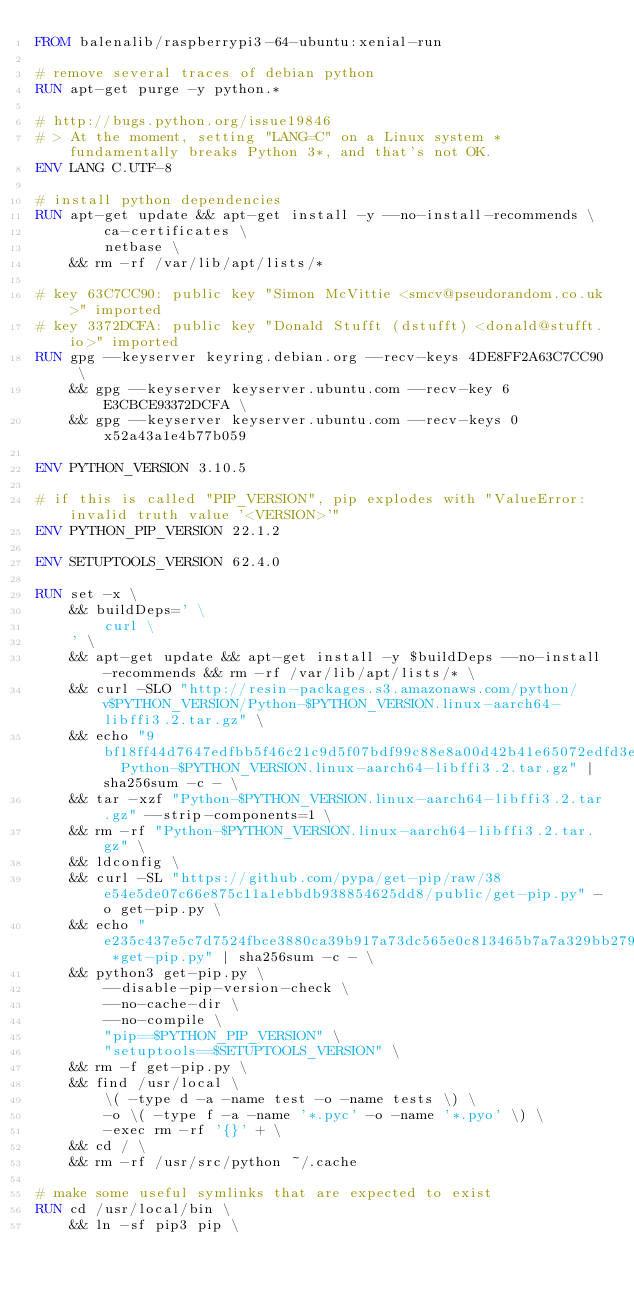<code> <loc_0><loc_0><loc_500><loc_500><_Dockerfile_>FROM balenalib/raspberrypi3-64-ubuntu:xenial-run

# remove several traces of debian python
RUN apt-get purge -y python.*

# http://bugs.python.org/issue19846
# > At the moment, setting "LANG=C" on a Linux system *fundamentally breaks Python 3*, and that's not OK.
ENV LANG C.UTF-8

# install python dependencies
RUN apt-get update && apt-get install -y --no-install-recommends \
		ca-certificates \
		netbase \
	&& rm -rf /var/lib/apt/lists/*

# key 63C7CC90: public key "Simon McVittie <smcv@pseudorandom.co.uk>" imported
# key 3372DCFA: public key "Donald Stufft (dstufft) <donald@stufft.io>" imported
RUN gpg --keyserver keyring.debian.org --recv-keys 4DE8FF2A63C7CC90 \
	&& gpg --keyserver keyserver.ubuntu.com --recv-key 6E3CBCE93372DCFA \
	&& gpg --keyserver keyserver.ubuntu.com --recv-keys 0x52a43a1e4b77b059

ENV PYTHON_VERSION 3.10.5

# if this is called "PIP_VERSION", pip explodes with "ValueError: invalid truth value '<VERSION>'"
ENV PYTHON_PIP_VERSION 22.1.2

ENV SETUPTOOLS_VERSION 62.4.0

RUN set -x \
	&& buildDeps=' \
		curl \
	' \
	&& apt-get update && apt-get install -y $buildDeps --no-install-recommends && rm -rf /var/lib/apt/lists/* \
	&& curl -SLO "http://resin-packages.s3.amazonaws.com/python/v$PYTHON_VERSION/Python-$PYTHON_VERSION.linux-aarch64-libffi3.2.tar.gz" \
	&& echo "9bf18ff44d7647edfbb5f46c21c9d5f07bdf99c88e8a00d42b41e65072edfd3e  Python-$PYTHON_VERSION.linux-aarch64-libffi3.2.tar.gz" | sha256sum -c - \
	&& tar -xzf "Python-$PYTHON_VERSION.linux-aarch64-libffi3.2.tar.gz" --strip-components=1 \
	&& rm -rf "Python-$PYTHON_VERSION.linux-aarch64-libffi3.2.tar.gz" \
	&& ldconfig \
	&& curl -SL "https://github.com/pypa/get-pip/raw/38e54e5de07c66e875c11a1ebbdb938854625dd8/public/get-pip.py" -o get-pip.py \
    && echo "e235c437e5c7d7524fbce3880ca39b917a73dc565e0c813465b7a7a329bb279a *get-pip.py" | sha256sum -c - \
    && python3 get-pip.py \
        --disable-pip-version-check \
        --no-cache-dir \
        --no-compile \
        "pip==$PYTHON_PIP_VERSION" \
        "setuptools==$SETUPTOOLS_VERSION" \
	&& rm -f get-pip.py \
	&& find /usr/local \
		\( -type d -a -name test -o -name tests \) \
		-o \( -type f -a -name '*.pyc' -o -name '*.pyo' \) \
		-exec rm -rf '{}' + \
	&& cd / \
	&& rm -rf /usr/src/python ~/.cache

# make some useful symlinks that are expected to exist
RUN cd /usr/local/bin \
	&& ln -sf pip3 pip \</code> 